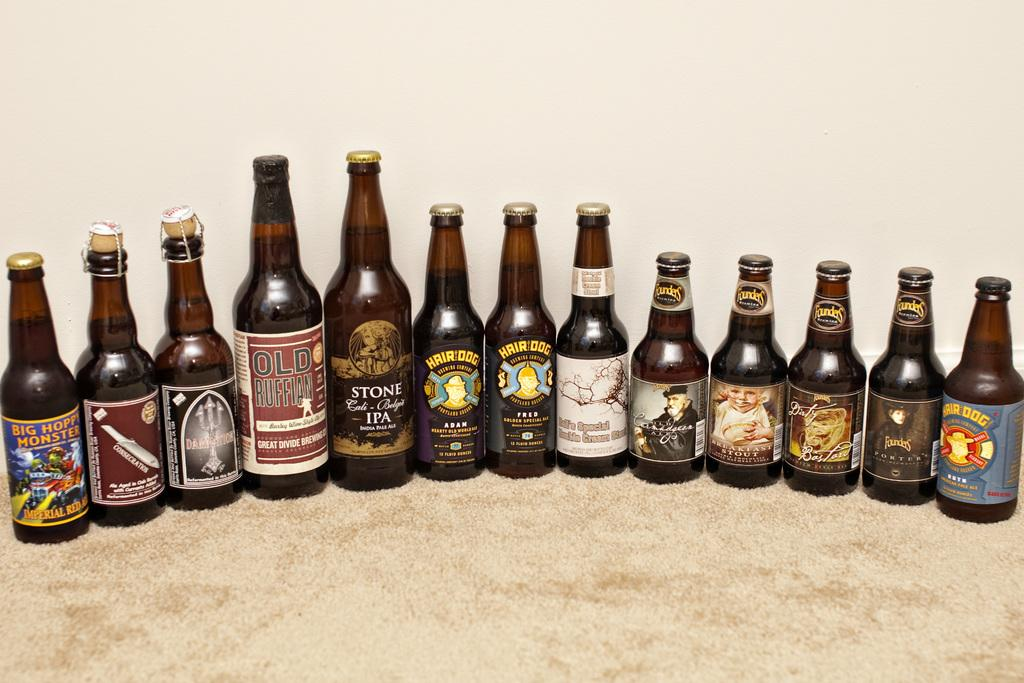<image>
Relay a brief, clear account of the picture shown. Old Ruffian and Hair Dog bottles among those lines up on the carpet. 